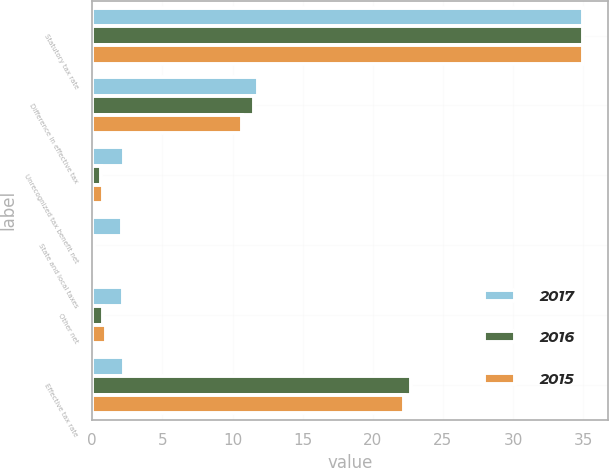Convert chart. <chart><loc_0><loc_0><loc_500><loc_500><stacked_bar_chart><ecel><fcel>Statutory tax rate<fcel>Difference in effective tax<fcel>Unrecognized tax benefit net<fcel>State and local taxes<fcel>Other net<fcel>Effective tax rate<nl><fcel>2017<fcel>35<fcel>11.8<fcel>2.3<fcel>2.1<fcel>2.2<fcel>2.3<nl><fcel>2016<fcel>35<fcel>11.5<fcel>0.6<fcel>0.1<fcel>0.8<fcel>22.7<nl><fcel>2015<fcel>35<fcel>10.7<fcel>0.8<fcel>0.1<fcel>1<fcel>22.2<nl></chart> 